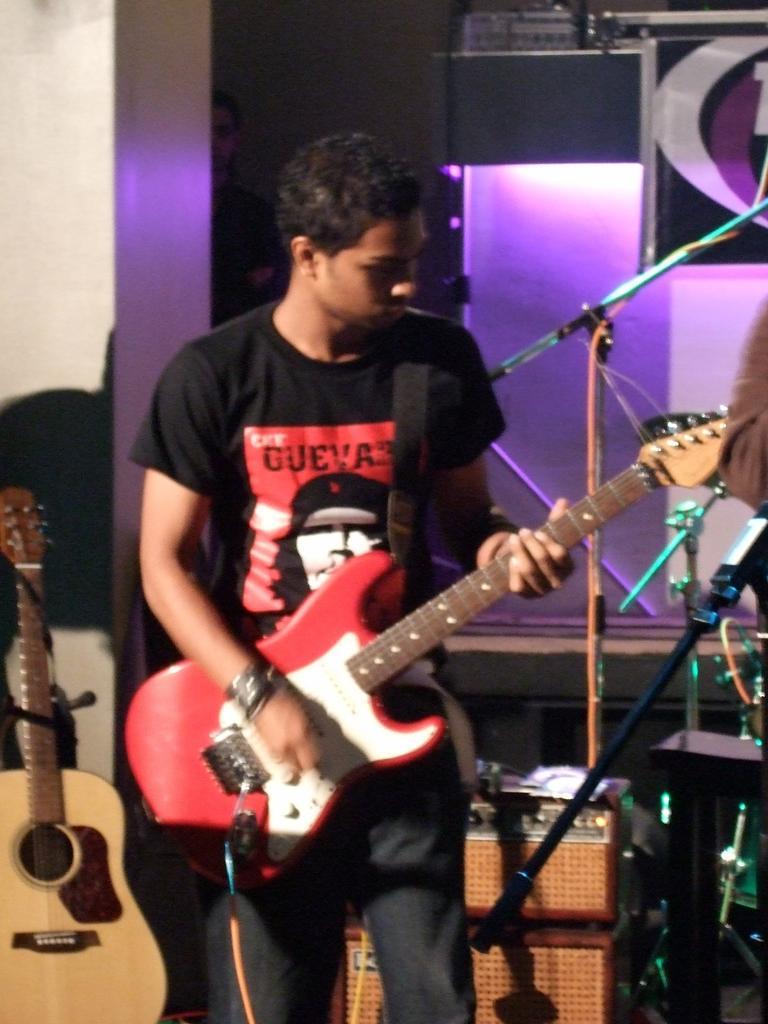Please provide a concise description of this image. In this picture a man is playing guitar in front of microphone, in the background we can see couple of lights and musical instruments. 